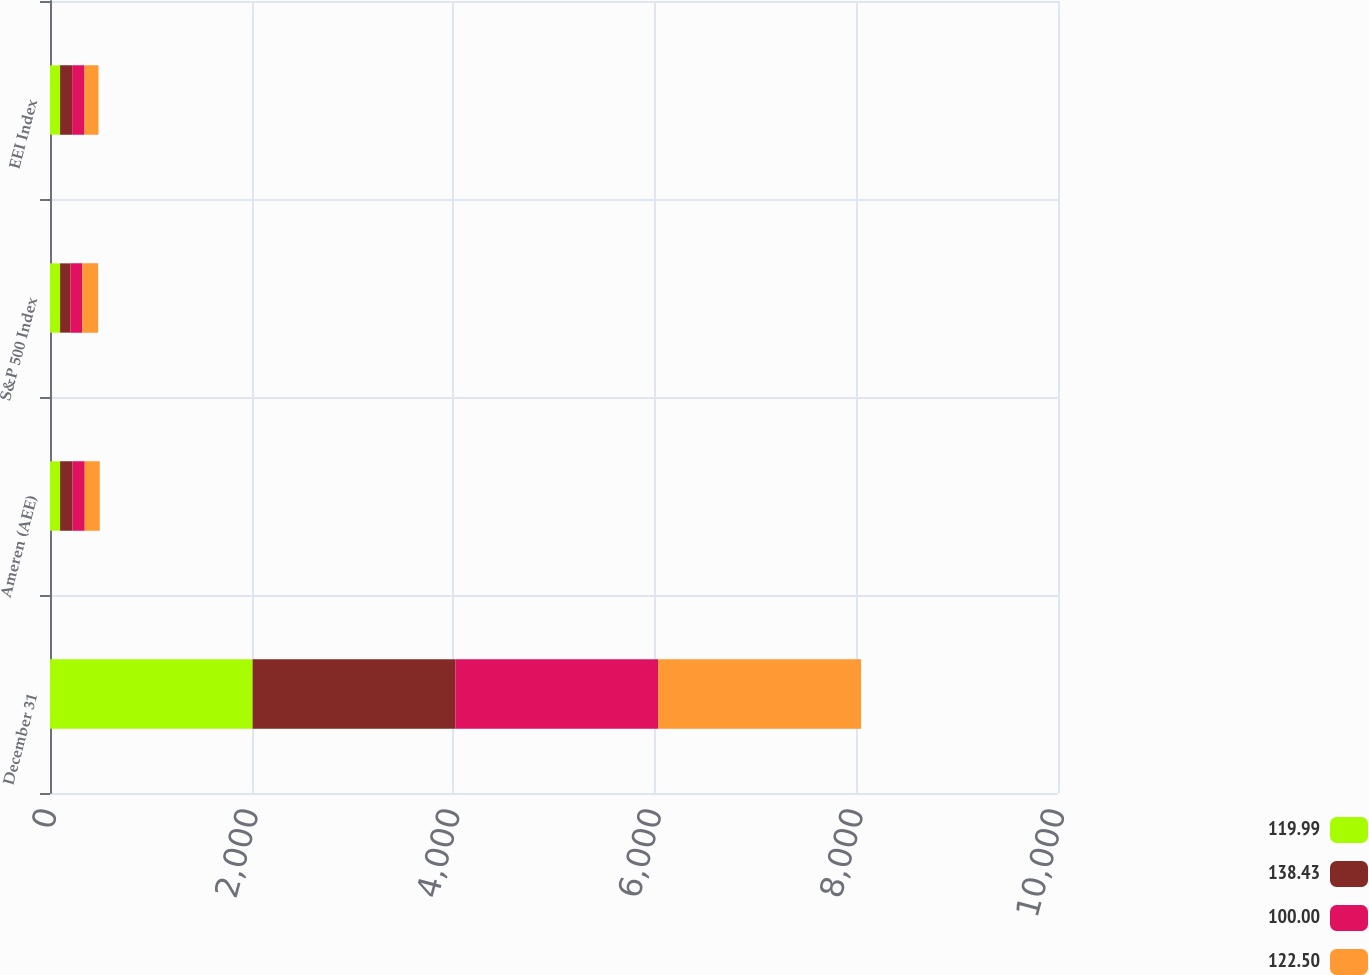<chart> <loc_0><loc_0><loc_500><loc_500><stacked_bar_chart><ecel><fcel>December 31<fcel>Ameren (AEE)<fcel>S&P 500 Index<fcel>EEI Index<nl><fcel>119.99<fcel>2010<fcel>100<fcel>100<fcel>100<nl><fcel>138.43<fcel>2011<fcel>123.92<fcel>102.11<fcel>119.99<nl><fcel>100<fcel>2012<fcel>120.78<fcel>118.45<fcel>122.5<nl><fcel>122.5<fcel>2013<fcel>148.94<fcel>156.81<fcel>138.43<nl></chart> 